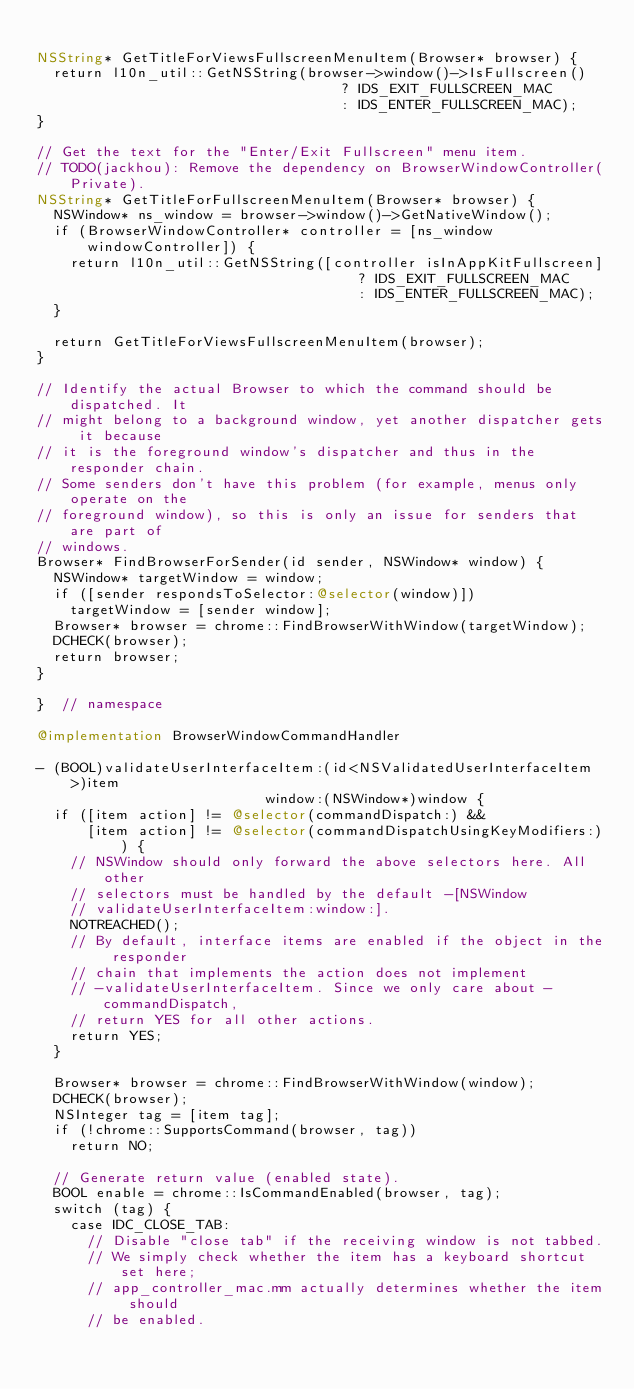Convert code to text. <code><loc_0><loc_0><loc_500><loc_500><_ObjectiveC_>
NSString* GetTitleForViewsFullscreenMenuItem(Browser* browser) {
  return l10n_util::GetNSString(browser->window()->IsFullscreen()
                                    ? IDS_EXIT_FULLSCREEN_MAC
                                    : IDS_ENTER_FULLSCREEN_MAC);
}

// Get the text for the "Enter/Exit Fullscreen" menu item.
// TODO(jackhou): Remove the dependency on BrowserWindowController(Private).
NSString* GetTitleForFullscreenMenuItem(Browser* browser) {
  NSWindow* ns_window = browser->window()->GetNativeWindow();
  if (BrowserWindowController* controller = [ns_window windowController]) {
    return l10n_util::GetNSString([controller isInAppKitFullscreen]
                                      ? IDS_EXIT_FULLSCREEN_MAC
                                      : IDS_ENTER_FULLSCREEN_MAC);
  }

  return GetTitleForViewsFullscreenMenuItem(browser);
}

// Identify the actual Browser to which the command should be dispatched. It
// might belong to a background window, yet another dispatcher gets it because
// it is the foreground window's dispatcher and thus in the responder chain.
// Some senders don't have this problem (for example, menus only operate on the
// foreground window), so this is only an issue for senders that are part of
// windows.
Browser* FindBrowserForSender(id sender, NSWindow* window) {
  NSWindow* targetWindow = window;
  if ([sender respondsToSelector:@selector(window)])
    targetWindow = [sender window];
  Browser* browser = chrome::FindBrowserWithWindow(targetWindow);
  DCHECK(browser);
  return browser;
}

}  // namespace

@implementation BrowserWindowCommandHandler

- (BOOL)validateUserInterfaceItem:(id<NSValidatedUserInterfaceItem>)item
                           window:(NSWindow*)window {
  if ([item action] != @selector(commandDispatch:) &&
      [item action] != @selector(commandDispatchUsingKeyModifiers:)) {
    // NSWindow should only forward the above selectors here. All other
    // selectors must be handled by the default -[NSWindow
    // validateUserInterfaceItem:window:].
    NOTREACHED();
    // By default, interface items are enabled if the object in the responder
    // chain that implements the action does not implement
    // -validateUserInterfaceItem. Since we only care about -commandDispatch,
    // return YES for all other actions.
    return YES;
  }

  Browser* browser = chrome::FindBrowserWithWindow(window);
  DCHECK(browser);
  NSInteger tag = [item tag];
  if (!chrome::SupportsCommand(browser, tag))
    return NO;

  // Generate return value (enabled state).
  BOOL enable = chrome::IsCommandEnabled(browser, tag);
  switch (tag) {
    case IDC_CLOSE_TAB:
      // Disable "close tab" if the receiving window is not tabbed.
      // We simply check whether the item has a keyboard shortcut set here;
      // app_controller_mac.mm actually determines whether the item should
      // be enabled.</code> 